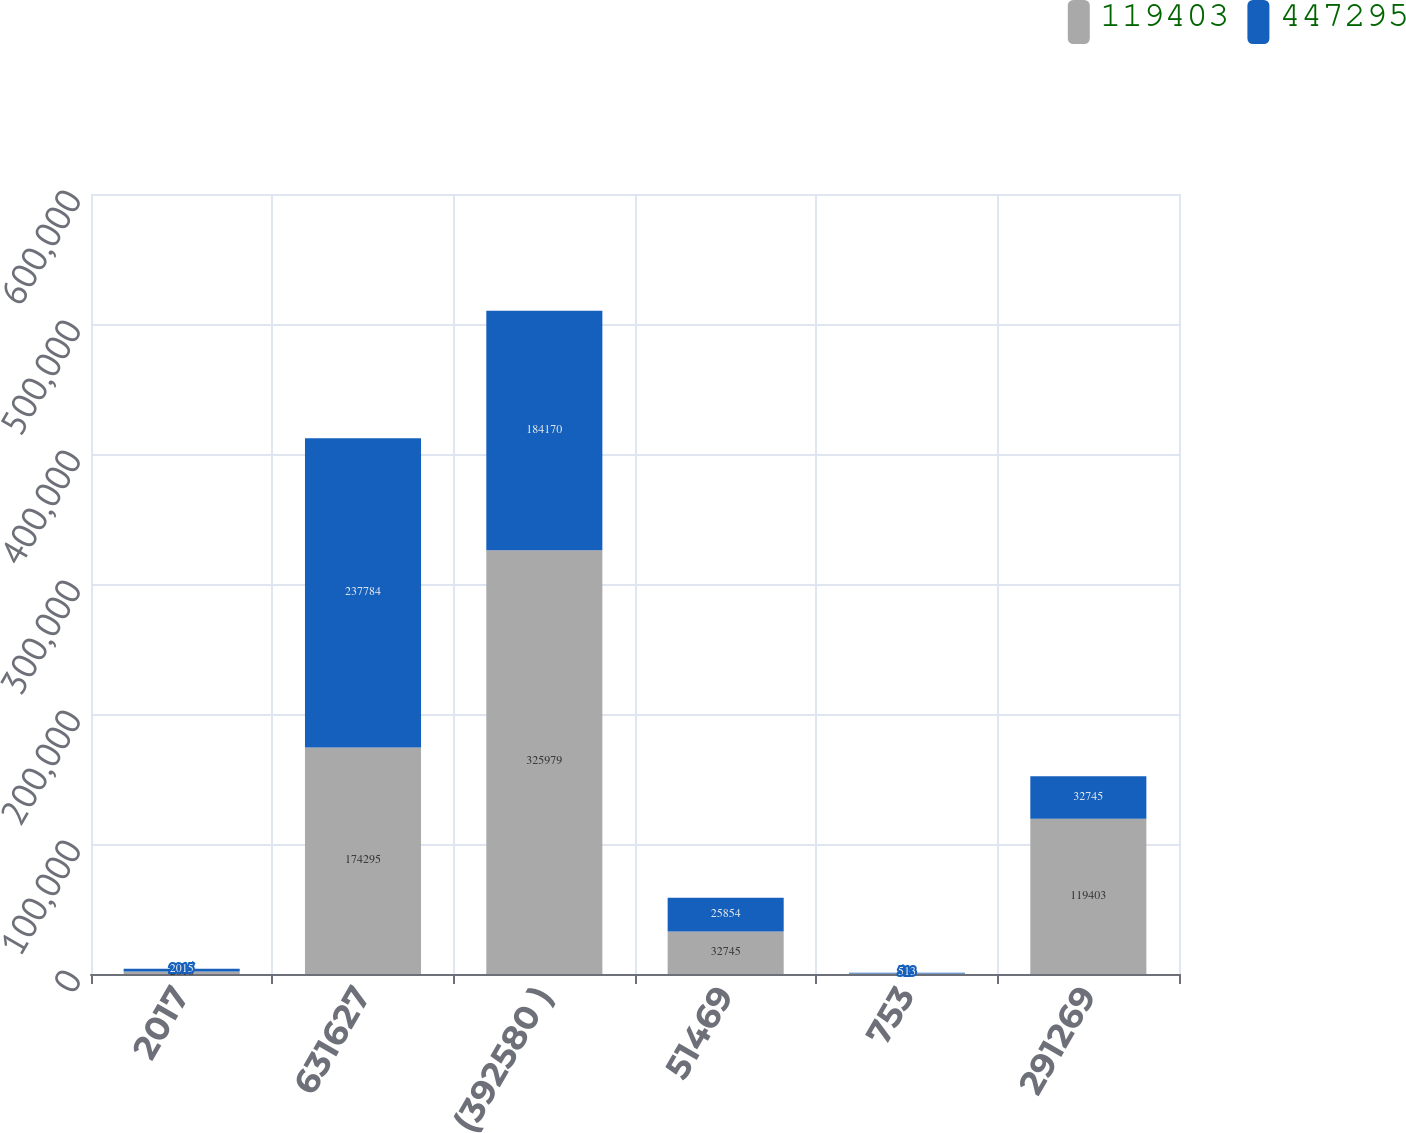Convert chart to OTSL. <chart><loc_0><loc_0><loc_500><loc_500><stacked_bar_chart><ecel><fcel>2017<fcel>631627<fcel>(392580 )<fcel>51469<fcel>753<fcel>291269<nl><fcel>119403<fcel>2016<fcel>174295<fcel>325979<fcel>32745<fcel>464<fcel>119403<nl><fcel>447295<fcel>2015<fcel>237784<fcel>184170<fcel>25854<fcel>513<fcel>32745<nl></chart> 